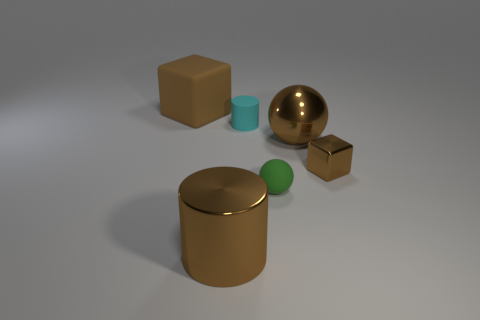Add 4 green things. How many objects exist? 10 Subtract all cylinders. How many objects are left? 4 Add 2 small green matte spheres. How many small green matte spheres are left? 3 Add 1 large cyan shiny cylinders. How many large cyan shiny cylinders exist? 1 Subtract 1 cyan cylinders. How many objects are left? 5 Subtract all small cyan things. Subtract all brown things. How many objects are left? 1 